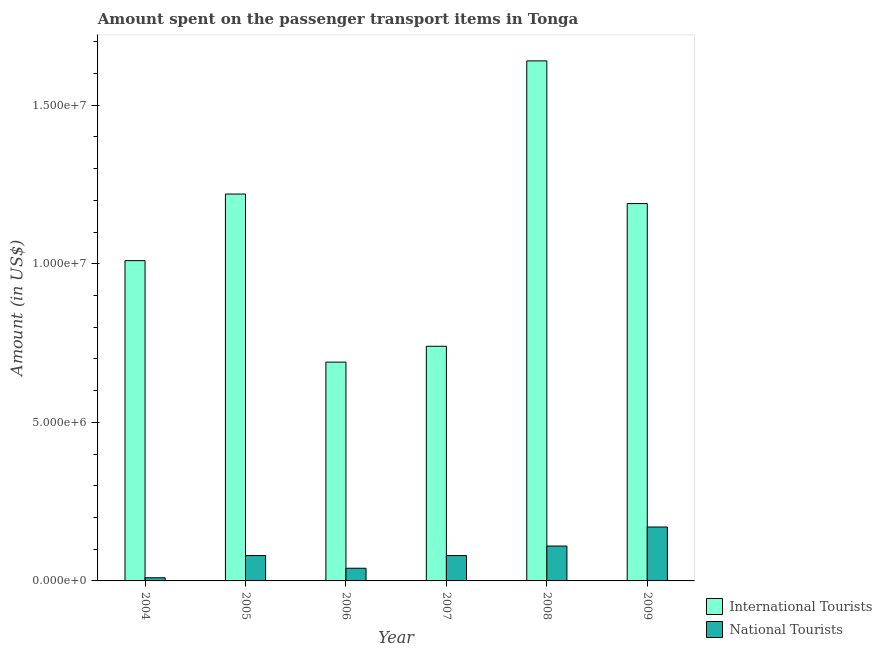Are the number of bars per tick equal to the number of legend labels?
Offer a terse response. Yes. Are the number of bars on each tick of the X-axis equal?
Provide a succinct answer. Yes. What is the label of the 3rd group of bars from the left?
Offer a very short reply. 2006. In how many cases, is the number of bars for a given year not equal to the number of legend labels?
Make the answer very short. 0. What is the amount spent on transport items of national tourists in 2004?
Keep it short and to the point. 1.00e+05. Across all years, what is the maximum amount spent on transport items of national tourists?
Give a very brief answer. 1.70e+06. Across all years, what is the minimum amount spent on transport items of international tourists?
Make the answer very short. 6.90e+06. In which year was the amount spent on transport items of national tourists maximum?
Keep it short and to the point. 2009. In which year was the amount spent on transport items of national tourists minimum?
Ensure brevity in your answer.  2004. What is the total amount spent on transport items of national tourists in the graph?
Provide a succinct answer. 4.90e+06. What is the difference between the amount spent on transport items of national tourists in 2008 and that in 2009?
Give a very brief answer. -6.00e+05. What is the difference between the amount spent on transport items of national tourists in 2005 and the amount spent on transport items of international tourists in 2007?
Keep it short and to the point. 0. What is the average amount spent on transport items of international tourists per year?
Your response must be concise. 1.08e+07. In the year 2007, what is the difference between the amount spent on transport items of national tourists and amount spent on transport items of international tourists?
Your answer should be compact. 0. What is the ratio of the amount spent on transport items of national tourists in 2007 to that in 2008?
Provide a succinct answer. 0.73. What is the difference between the highest and the lowest amount spent on transport items of international tourists?
Make the answer very short. 9.50e+06. In how many years, is the amount spent on transport items of international tourists greater than the average amount spent on transport items of international tourists taken over all years?
Ensure brevity in your answer.  3. What does the 1st bar from the left in 2007 represents?
Ensure brevity in your answer.  International Tourists. What does the 2nd bar from the right in 2009 represents?
Give a very brief answer. International Tourists. How many bars are there?
Provide a short and direct response. 12. How many years are there in the graph?
Make the answer very short. 6. Does the graph contain any zero values?
Your response must be concise. No. How many legend labels are there?
Provide a short and direct response. 2. What is the title of the graph?
Ensure brevity in your answer.  Amount spent on the passenger transport items in Tonga. What is the label or title of the Y-axis?
Provide a succinct answer. Amount (in US$). What is the Amount (in US$) of International Tourists in 2004?
Your answer should be very brief. 1.01e+07. What is the Amount (in US$) in International Tourists in 2005?
Your answer should be compact. 1.22e+07. What is the Amount (in US$) in National Tourists in 2005?
Your answer should be compact. 8.00e+05. What is the Amount (in US$) in International Tourists in 2006?
Offer a very short reply. 6.90e+06. What is the Amount (in US$) in International Tourists in 2007?
Provide a succinct answer. 7.40e+06. What is the Amount (in US$) of International Tourists in 2008?
Your answer should be very brief. 1.64e+07. What is the Amount (in US$) in National Tourists in 2008?
Keep it short and to the point. 1.10e+06. What is the Amount (in US$) in International Tourists in 2009?
Keep it short and to the point. 1.19e+07. What is the Amount (in US$) of National Tourists in 2009?
Offer a very short reply. 1.70e+06. Across all years, what is the maximum Amount (in US$) in International Tourists?
Provide a succinct answer. 1.64e+07. Across all years, what is the maximum Amount (in US$) in National Tourists?
Provide a short and direct response. 1.70e+06. Across all years, what is the minimum Amount (in US$) of International Tourists?
Your answer should be very brief. 6.90e+06. What is the total Amount (in US$) of International Tourists in the graph?
Provide a short and direct response. 6.49e+07. What is the total Amount (in US$) of National Tourists in the graph?
Offer a terse response. 4.90e+06. What is the difference between the Amount (in US$) of International Tourists in 2004 and that in 2005?
Your answer should be very brief. -2.10e+06. What is the difference between the Amount (in US$) of National Tourists in 2004 and that in 2005?
Provide a short and direct response. -7.00e+05. What is the difference between the Amount (in US$) in International Tourists in 2004 and that in 2006?
Provide a short and direct response. 3.20e+06. What is the difference between the Amount (in US$) in International Tourists in 2004 and that in 2007?
Offer a very short reply. 2.70e+06. What is the difference between the Amount (in US$) in National Tourists in 2004 and that in 2007?
Your answer should be compact. -7.00e+05. What is the difference between the Amount (in US$) in International Tourists in 2004 and that in 2008?
Offer a very short reply. -6.30e+06. What is the difference between the Amount (in US$) in National Tourists in 2004 and that in 2008?
Keep it short and to the point. -1.00e+06. What is the difference between the Amount (in US$) in International Tourists in 2004 and that in 2009?
Make the answer very short. -1.80e+06. What is the difference between the Amount (in US$) of National Tourists in 2004 and that in 2009?
Provide a short and direct response. -1.60e+06. What is the difference between the Amount (in US$) of International Tourists in 2005 and that in 2006?
Offer a terse response. 5.30e+06. What is the difference between the Amount (in US$) of National Tourists in 2005 and that in 2006?
Keep it short and to the point. 4.00e+05. What is the difference between the Amount (in US$) of International Tourists in 2005 and that in 2007?
Provide a short and direct response. 4.80e+06. What is the difference between the Amount (in US$) in International Tourists in 2005 and that in 2008?
Make the answer very short. -4.20e+06. What is the difference between the Amount (in US$) in National Tourists in 2005 and that in 2009?
Offer a terse response. -9.00e+05. What is the difference between the Amount (in US$) in International Tourists in 2006 and that in 2007?
Give a very brief answer. -5.00e+05. What is the difference between the Amount (in US$) in National Tourists in 2006 and that in 2007?
Offer a terse response. -4.00e+05. What is the difference between the Amount (in US$) of International Tourists in 2006 and that in 2008?
Keep it short and to the point. -9.50e+06. What is the difference between the Amount (in US$) in National Tourists in 2006 and that in 2008?
Your response must be concise. -7.00e+05. What is the difference between the Amount (in US$) of International Tourists in 2006 and that in 2009?
Offer a terse response. -5.00e+06. What is the difference between the Amount (in US$) of National Tourists in 2006 and that in 2009?
Provide a succinct answer. -1.30e+06. What is the difference between the Amount (in US$) in International Tourists in 2007 and that in 2008?
Make the answer very short. -9.00e+06. What is the difference between the Amount (in US$) in National Tourists in 2007 and that in 2008?
Your answer should be very brief. -3.00e+05. What is the difference between the Amount (in US$) in International Tourists in 2007 and that in 2009?
Make the answer very short. -4.50e+06. What is the difference between the Amount (in US$) of National Tourists in 2007 and that in 2009?
Your response must be concise. -9.00e+05. What is the difference between the Amount (in US$) in International Tourists in 2008 and that in 2009?
Ensure brevity in your answer.  4.50e+06. What is the difference between the Amount (in US$) in National Tourists in 2008 and that in 2009?
Offer a terse response. -6.00e+05. What is the difference between the Amount (in US$) in International Tourists in 2004 and the Amount (in US$) in National Tourists in 2005?
Your response must be concise. 9.30e+06. What is the difference between the Amount (in US$) of International Tourists in 2004 and the Amount (in US$) of National Tourists in 2006?
Make the answer very short. 9.70e+06. What is the difference between the Amount (in US$) of International Tourists in 2004 and the Amount (in US$) of National Tourists in 2007?
Offer a very short reply. 9.30e+06. What is the difference between the Amount (in US$) in International Tourists in 2004 and the Amount (in US$) in National Tourists in 2008?
Your answer should be compact. 9.00e+06. What is the difference between the Amount (in US$) in International Tourists in 2004 and the Amount (in US$) in National Tourists in 2009?
Provide a short and direct response. 8.40e+06. What is the difference between the Amount (in US$) in International Tourists in 2005 and the Amount (in US$) in National Tourists in 2006?
Provide a succinct answer. 1.18e+07. What is the difference between the Amount (in US$) in International Tourists in 2005 and the Amount (in US$) in National Tourists in 2007?
Offer a terse response. 1.14e+07. What is the difference between the Amount (in US$) in International Tourists in 2005 and the Amount (in US$) in National Tourists in 2008?
Ensure brevity in your answer.  1.11e+07. What is the difference between the Amount (in US$) in International Tourists in 2005 and the Amount (in US$) in National Tourists in 2009?
Provide a short and direct response. 1.05e+07. What is the difference between the Amount (in US$) of International Tourists in 2006 and the Amount (in US$) of National Tourists in 2007?
Offer a terse response. 6.10e+06. What is the difference between the Amount (in US$) in International Tourists in 2006 and the Amount (in US$) in National Tourists in 2008?
Provide a short and direct response. 5.80e+06. What is the difference between the Amount (in US$) of International Tourists in 2006 and the Amount (in US$) of National Tourists in 2009?
Make the answer very short. 5.20e+06. What is the difference between the Amount (in US$) of International Tourists in 2007 and the Amount (in US$) of National Tourists in 2008?
Your response must be concise. 6.30e+06. What is the difference between the Amount (in US$) in International Tourists in 2007 and the Amount (in US$) in National Tourists in 2009?
Ensure brevity in your answer.  5.70e+06. What is the difference between the Amount (in US$) of International Tourists in 2008 and the Amount (in US$) of National Tourists in 2009?
Offer a very short reply. 1.47e+07. What is the average Amount (in US$) of International Tourists per year?
Your answer should be compact. 1.08e+07. What is the average Amount (in US$) in National Tourists per year?
Keep it short and to the point. 8.17e+05. In the year 2005, what is the difference between the Amount (in US$) of International Tourists and Amount (in US$) of National Tourists?
Your response must be concise. 1.14e+07. In the year 2006, what is the difference between the Amount (in US$) of International Tourists and Amount (in US$) of National Tourists?
Your response must be concise. 6.50e+06. In the year 2007, what is the difference between the Amount (in US$) of International Tourists and Amount (in US$) of National Tourists?
Provide a succinct answer. 6.60e+06. In the year 2008, what is the difference between the Amount (in US$) of International Tourists and Amount (in US$) of National Tourists?
Ensure brevity in your answer.  1.53e+07. In the year 2009, what is the difference between the Amount (in US$) of International Tourists and Amount (in US$) of National Tourists?
Your answer should be very brief. 1.02e+07. What is the ratio of the Amount (in US$) in International Tourists in 2004 to that in 2005?
Offer a very short reply. 0.83. What is the ratio of the Amount (in US$) in International Tourists in 2004 to that in 2006?
Your answer should be compact. 1.46. What is the ratio of the Amount (in US$) in International Tourists in 2004 to that in 2007?
Offer a very short reply. 1.36. What is the ratio of the Amount (in US$) in International Tourists in 2004 to that in 2008?
Provide a short and direct response. 0.62. What is the ratio of the Amount (in US$) in National Tourists in 2004 to that in 2008?
Provide a short and direct response. 0.09. What is the ratio of the Amount (in US$) in International Tourists in 2004 to that in 2009?
Give a very brief answer. 0.85. What is the ratio of the Amount (in US$) in National Tourists in 2004 to that in 2009?
Your answer should be compact. 0.06. What is the ratio of the Amount (in US$) of International Tourists in 2005 to that in 2006?
Keep it short and to the point. 1.77. What is the ratio of the Amount (in US$) in National Tourists in 2005 to that in 2006?
Your answer should be very brief. 2. What is the ratio of the Amount (in US$) of International Tourists in 2005 to that in 2007?
Offer a very short reply. 1.65. What is the ratio of the Amount (in US$) of National Tourists in 2005 to that in 2007?
Your answer should be compact. 1. What is the ratio of the Amount (in US$) in International Tourists in 2005 to that in 2008?
Provide a succinct answer. 0.74. What is the ratio of the Amount (in US$) in National Tourists in 2005 to that in 2008?
Your answer should be compact. 0.73. What is the ratio of the Amount (in US$) of International Tourists in 2005 to that in 2009?
Your response must be concise. 1.03. What is the ratio of the Amount (in US$) of National Tourists in 2005 to that in 2009?
Provide a succinct answer. 0.47. What is the ratio of the Amount (in US$) in International Tourists in 2006 to that in 2007?
Your answer should be very brief. 0.93. What is the ratio of the Amount (in US$) of National Tourists in 2006 to that in 2007?
Your answer should be very brief. 0.5. What is the ratio of the Amount (in US$) in International Tourists in 2006 to that in 2008?
Provide a short and direct response. 0.42. What is the ratio of the Amount (in US$) in National Tourists in 2006 to that in 2008?
Your answer should be very brief. 0.36. What is the ratio of the Amount (in US$) in International Tourists in 2006 to that in 2009?
Provide a short and direct response. 0.58. What is the ratio of the Amount (in US$) of National Tourists in 2006 to that in 2009?
Your response must be concise. 0.24. What is the ratio of the Amount (in US$) of International Tourists in 2007 to that in 2008?
Ensure brevity in your answer.  0.45. What is the ratio of the Amount (in US$) in National Tourists in 2007 to that in 2008?
Your answer should be very brief. 0.73. What is the ratio of the Amount (in US$) in International Tourists in 2007 to that in 2009?
Provide a short and direct response. 0.62. What is the ratio of the Amount (in US$) of National Tourists in 2007 to that in 2009?
Provide a succinct answer. 0.47. What is the ratio of the Amount (in US$) in International Tourists in 2008 to that in 2009?
Keep it short and to the point. 1.38. What is the ratio of the Amount (in US$) in National Tourists in 2008 to that in 2009?
Give a very brief answer. 0.65. What is the difference between the highest and the second highest Amount (in US$) in International Tourists?
Give a very brief answer. 4.20e+06. What is the difference between the highest and the second highest Amount (in US$) in National Tourists?
Offer a terse response. 6.00e+05. What is the difference between the highest and the lowest Amount (in US$) in International Tourists?
Your answer should be compact. 9.50e+06. What is the difference between the highest and the lowest Amount (in US$) in National Tourists?
Provide a succinct answer. 1.60e+06. 